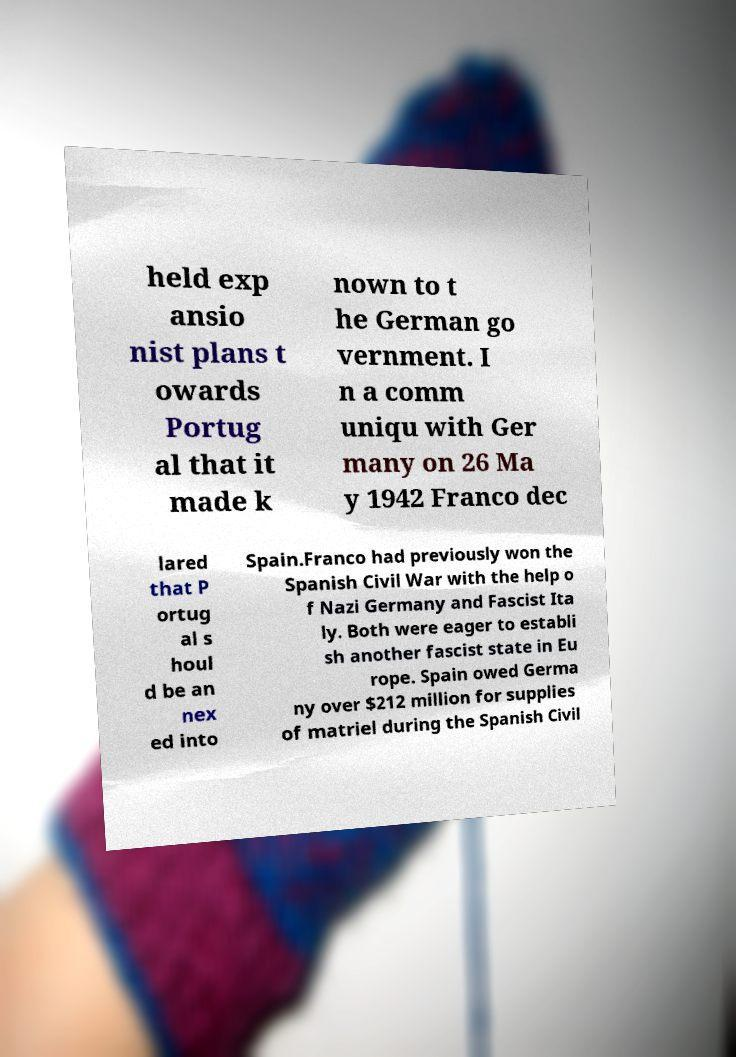What messages or text are displayed in this image? I need them in a readable, typed format. held exp ansio nist plans t owards Portug al that it made k nown to t he German go vernment. I n a comm uniqu with Ger many on 26 Ma y 1942 Franco dec lared that P ortug al s houl d be an nex ed into Spain.Franco had previously won the Spanish Civil War with the help o f Nazi Germany and Fascist Ita ly. Both were eager to establi sh another fascist state in Eu rope. Spain owed Germa ny over $212 million for supplies of matriel during the Spanish Civil 